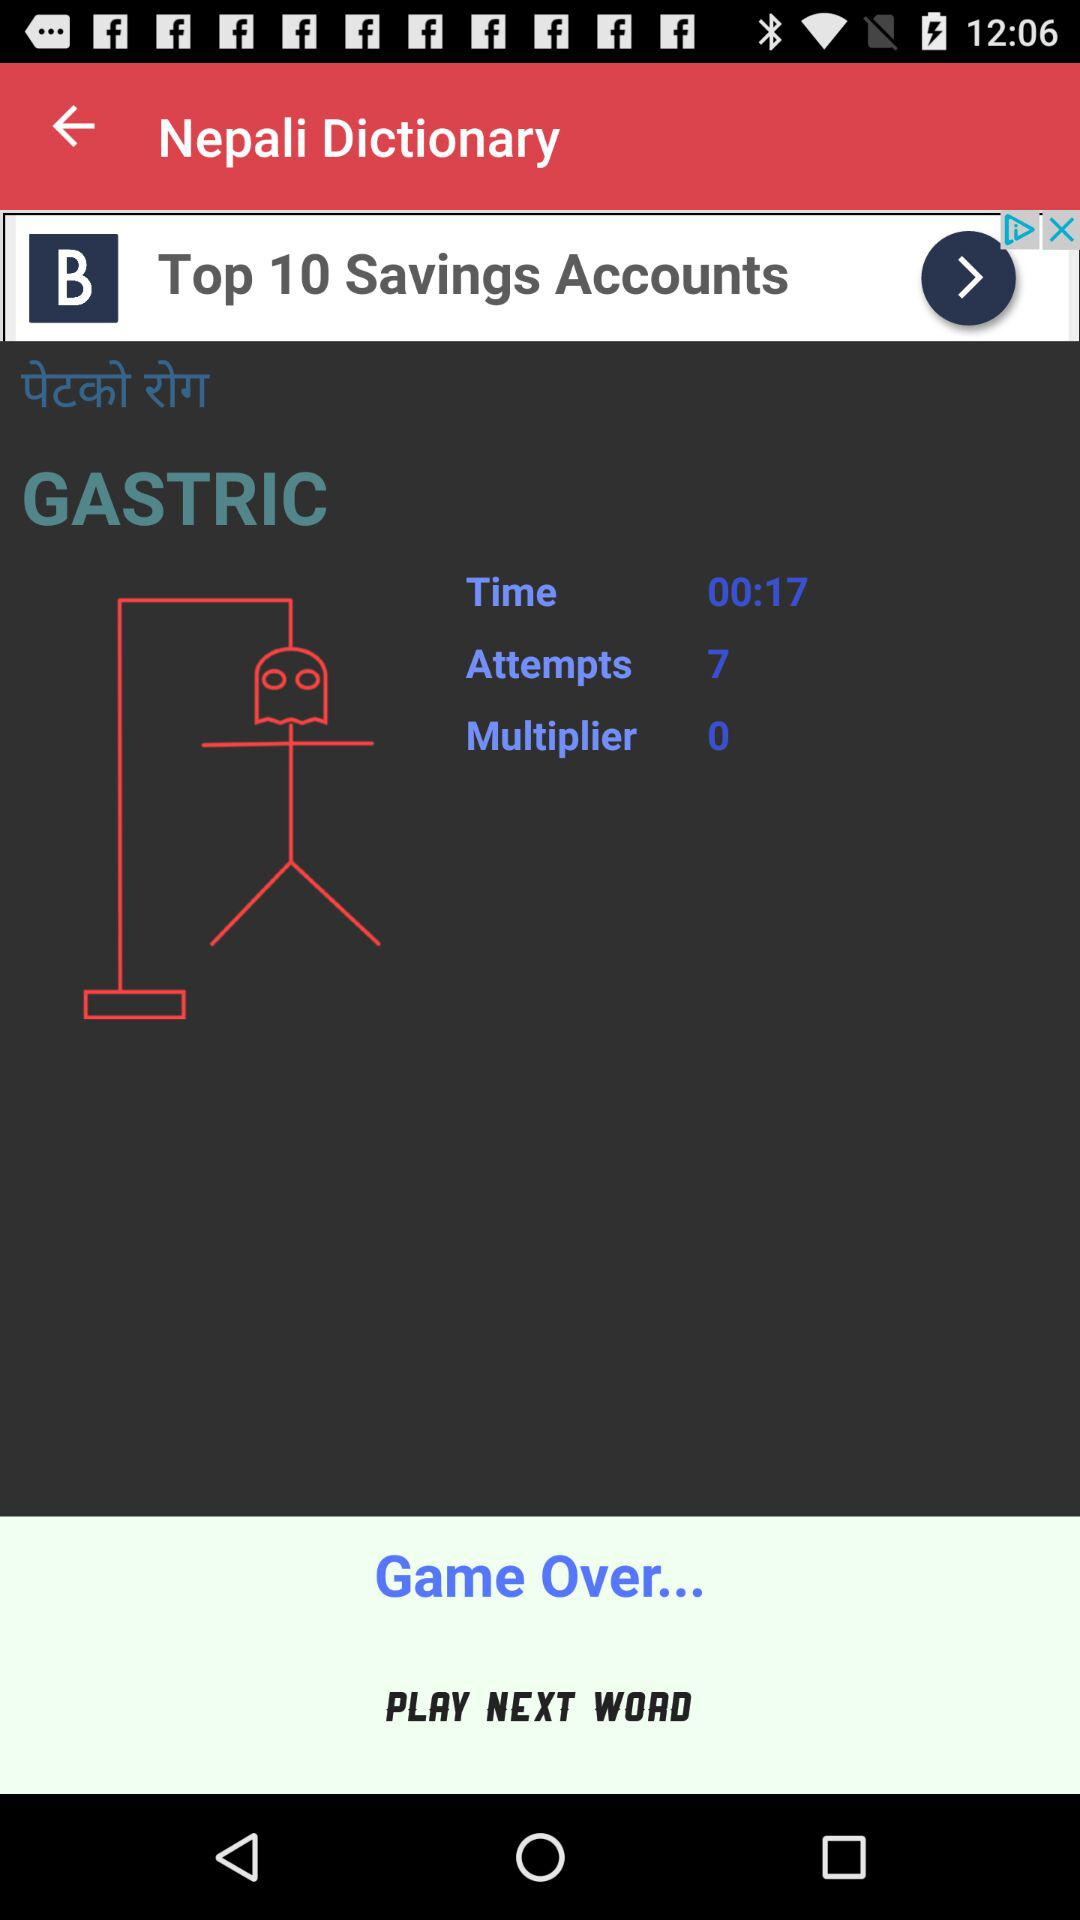What is the time duration? The time duration is 17 seconds. 